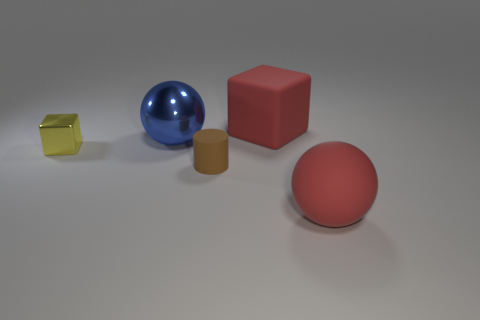Add 1 blue spheres. How many objects exist? 6 Subtract all blocks. How many objects are left? 3 Subtract 0 red cylinders. How many objects are left? 5 Subtract all small brown rubber cylinders. Subtract all small yellow objects. How many objects are left? 3 Add 5 big red blocks. How many big red blocks are left? 6 Add 2 tiny matte objects. How many tiny matte objects exist? 3 